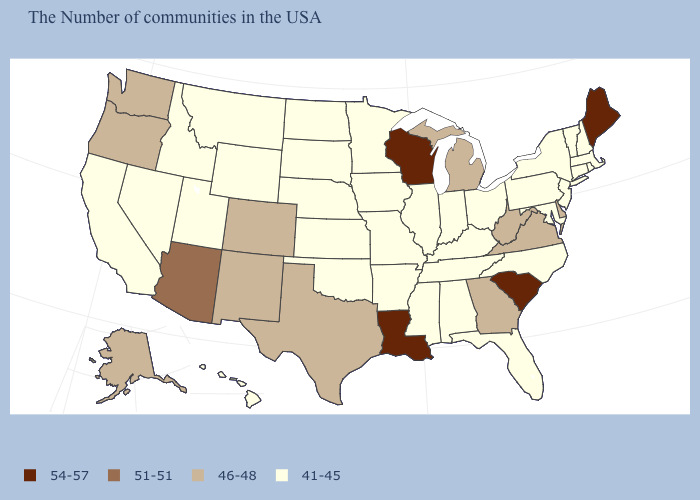Does Maine have the highest value in the USA?
Quick response, please. Yes. What is the highest value in states that border Vermont?
Concise answer only. 41-45. What is the value of Virginia?
Concise answer only. 46-48. Does the map have missing data?
Give a very brief answer. No. Name the states that have a value in the range 51-51?
Quick response, please. Arizona. Which states have the lowest value in the USA?
Write a very short answer. Massachusetts, Rhode Island, New Hampshire, Vermont, Connecticut, New York, New Jersey, Maryland, Pennsylvania, North Carolina, Ohio, Florida, Kentucky, Indiana, Alabama, Tennessee, Illinois, Mississippi, Missouri, Arkansas, Minnesota, Iowa, Kansas, Nebraska, Oklahoma, South Dakota, North Dakota, Wyoming, Utah, Montana, Idaho, Nevada, California, Hawaii. What is the value of New Mexico?
Write a very short answer. 46-48. Name the states that have a value in the range 41-45?
Quick response, please. Massachusetts, Rhode Island, New Hampshire, Vermont, Connecticut, New York, New Jersey, Maryland, Pennsylvania, North Carolina, Ohio, Florida, Kentucky, Indiana, Alabama, Tennessee, Illinois, Mississippi, Missouri, Arkansas, Minnesota, Iowa, Kansas, Nebraska, Oklahoma, South Dakota, North Dakota, Wyoming, Utah, Montana, Idaho, Nevada, California, Hawaii. What is the value of Georgia?
Write a very short answer. 46-48. What is the value of Wisconsin?
Keep it brief. 54-57. What is the lowest value in states that border Wisconsin?
Short answer required. 41-45. What is the value of Hawaii?
Give a very brief answer. 41-45. Does Wyoming have a higher value than Louisiana?
Quick response, please. No. Which states have the lowest value in the South?
Write a very short answer. Maryland, North Carolina, Florida, Kentucky, Alabama, Tennessee, Mississippi, Arkansas, Oklahoma. Name the states that have a value in the range 46-48?
Give a very brief answer. Delaware, Virginia, West Virginia, Georgia, Michigan, Texas, Colorado, New Mexico, Washington, Oregon, Alaska. 